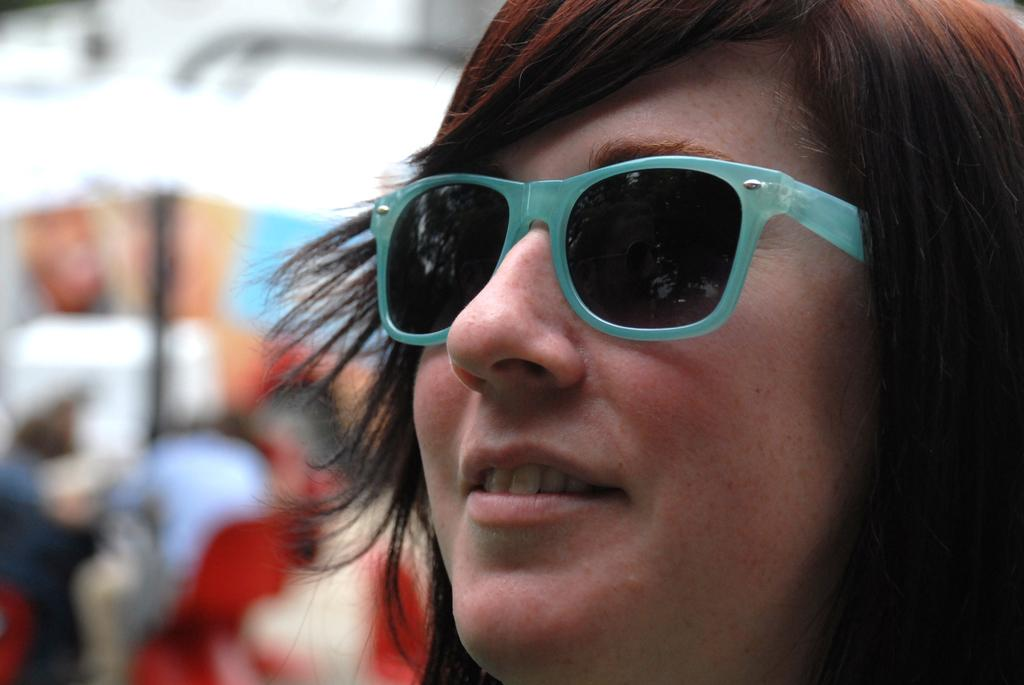What is the main subject of the image? There is a person in the image. What is the person wearing in the image? The person is wearing goggles. Can you describe the background of the image? The background of the image is blurred. What type of root can be seen growing from the person's dress in the image? There is no root growing from the person's dress in the image, as they are wearing goggles and not a dress. 